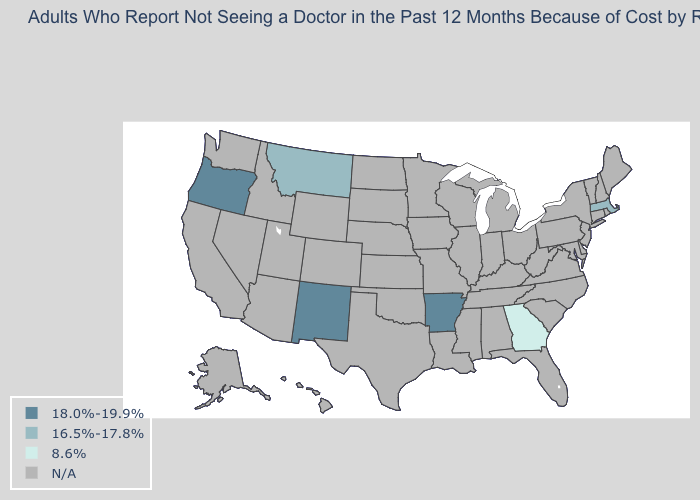Does Georgia have the highest value in the South?
Concise answer only. No. What is the value of Alaska?
Answer briefly. N/A. Name the states that have a value in the range 8.6%?
Answer briefly. Georgia. Name the states that have a value in the range N/A?
Be succinct. Alabama, Alaska, Arizona, California, Colorado, Connecticut, Delaware, Florida, Hawaii, Idaho, Illinois, Indiana, Iowa, Kansas, Kentucky, Louisiana, Maine, Maryland, Michigan, Minnesota, Mississippi, Missouri, Nebraska, Nevada, New Hampshire, New Jersey, New York, North Carolina, North Dakota, Ohio, Oklahoma, Pennsylvania, Rhode Island, South Carolina, South Dakota, Tennessee, Texas, Utah, Vermont, Virginia, Washington, West Virginia, Wisconsin, Wyoming. What is the value of New Jersey?
Write a very short answer. N/A. Name the states that have a value in the range N/A?
Quick response, please. Alabama, Alaska, Arizona, California, Colorado, Connecticut, Delaware, Florida, Hawaii, Idaho, Illinois, Indiana, Iowa, Kansas, Kentucky, Louisiana, Maine, Maryland, Michigan, Minnesota, Mississippi, Missouri, Nebraska, Nevada, New Hampshire, New Jersey, New York, North Carolina, North Dakota, Ohio, Oklahoma, Pennsylvania, Rhode Island, South Carolina, South Dakota, Tennessee, Texas, Utah, Vermont, Virginia, Washington, West Virginia, Wisconsin, Wyoming. What is the value of Kansas?
Answer briefly. N/A. What is the value of Maine?
Answer briefly. N/A. What is the value of Alaska?
Quick response, please. N/A. What is the value of Arizona?
Be succinct. N/A. Name the states that have a value in the range 8.6%?
Answer briefly. Georgia. What is the highest value in the USA?
Write a very short answer. 18.0%-19.9%. Does the map have missing data?
Be succinct. Yes. 